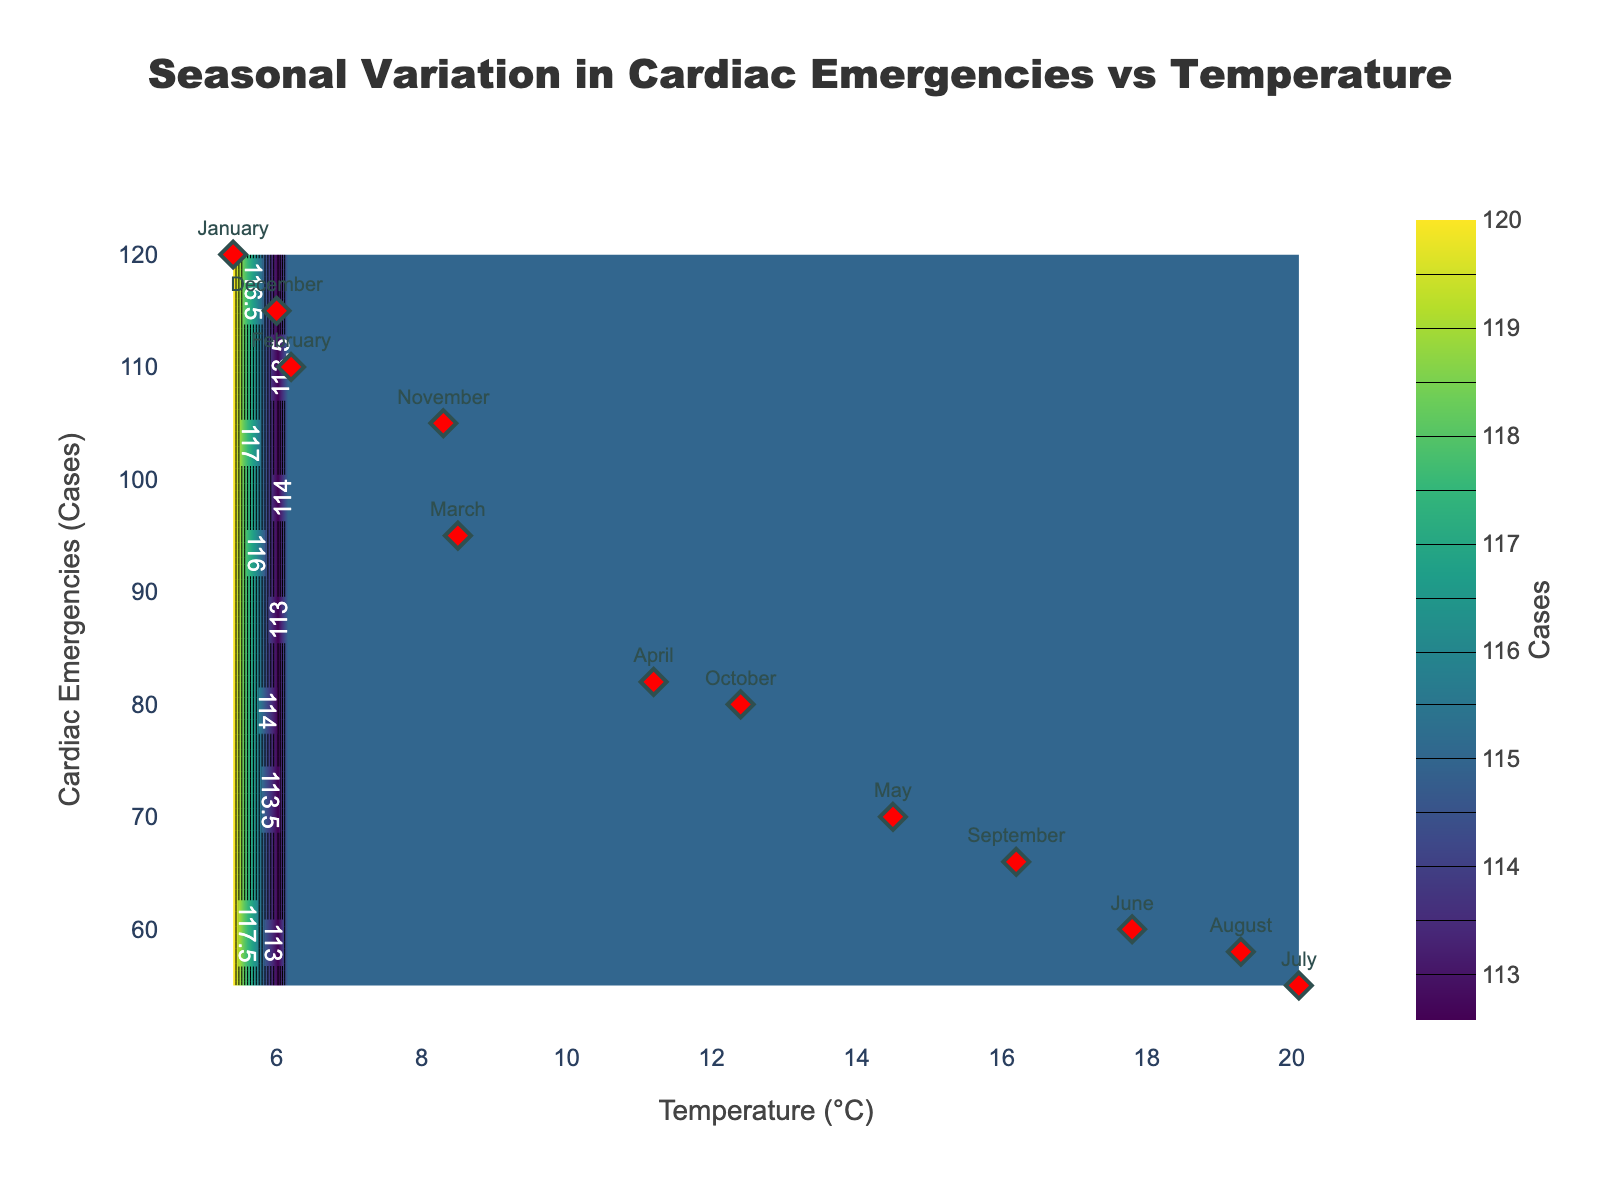How does the occurrence of cardiac emergencies vary with temperature according to the figure? The contour plot shows a heatmap with the x-axis representing temperature and the y-axis representing cardiac emergencies. The density of cases decreases as temperature increases, indicating that cardiac emergencies are more frequent in colder months.
Answer: Cardiac emergencies decrease as temperature increases What is the highest number of cardiac emergencies recorded and during which month did it occur? The scatter plot shows the actual data points with month labels. The highest number of cardiac emergencies recorded is 120, in January.
Answer: 120, January At what temperature does the contour plot show the lowest number of cardiac emergencies? The contour plot indicates that the lowest number of cardiac emergencies occurs at temperatures around 20.1°C. The label for July shows 55 cases at this temperature.
Answer: 20.1°C Compare the number of cardiac emergencies in January and July. According to the scatter plot, January has 120 cardiac emergencies, and July has 55. Subtracting these, January has 65 more cases than July.
Answer: January has 65 more cases than July What trend can be inferred from the seasonal variation shown in the figure? The scatter plot and contour plot together suggest a clear trend: cardiac emergencies are higher in colder months and lower in warmer months. This seasonal variation indicates that temperature might influence the occurrence of cardiac emergencies.
Answer: Higher in colder months, lower in warmer months Which month has the closest number of cardiac emergencies to the annual average, and what are those values? To find the answer, we first calculate the annual average: (120+110+95+82+70+60+55+58+66+80+105+115)/12 = 85.5. November has 105 cases, which is closest to this average.
Answer: November, 105 cases Are there more cardiac emergencies in February or April? By how much? February has 110 cardiac emergencies, and April has 82. The difference is 110 - 82 = 28, so there are 28 more emergencies in February.
Answer: February by 28 more cases What is the contour plot color scheme and what does it signify? The contour plot uses a 'Viridis' color scheme, where darker colors represent fewer cases and lighter colors represent more cases. This helps to visualize the density of cardiac emergencies with respect to temperature.
Answer: 'Viridis' color scheme showing density of cases Does the figure indicate any months with outliers in terms of cardiac emergencies? By examining the scatter plot, we see that January and December have notably high cardiac emergencies compared to other months, suggesting they are outliers.
Answer: January and December 